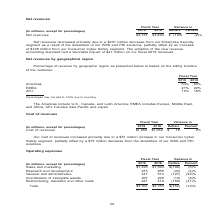According to Nortonlifelock's financial document, Why did Amortization of intangible assets decrease primarily due to? Based on the financial document, the answer is intangible assets sold with the divestiture of WSS and PKI solutions. Also, What is the decrease in  Sales and marketing from Fiscal year 2018 to 2019? According to the financial document, 100 (in millions). The relevant text states: "percentages) Sales and marketing $1,493 $1,593 $(100) (6)% Research and development 913 956 (43) (4)% General and administrative 447 574 (127) (22)% Amo..." Also, What is the decrease in  Research and development  from Fiscal year 2018 to 2019? According to the financial document, 43 (in millions). The relevant text states: "593 $(100) (6)% Research and development 913 956 (43) (4)% General and administrative 447 574 (127) (22)% Amortization of intangible assets 207 220 (13)..." Also, can you calculate: What is the total operating expense of fiscal years 2018 and 2019? Based on the calculation: 3,301+3,753, the result is 7054 (in millions). This is based on the information: "Total $3,301 $3,753 $(452) (12)% Total $3,301 $3,753 $(452) (12)%..." The key data points involved are: 3,301, 3,753. Also, can you calculate: What is the total impact on the decrease in Sales and marketing expense from stock-based compensation expense and divestiture of our WSS and PKI solutions? Based on the calculation: 51+41, the result is 92 (in millions). This is based on the information: "turing, transition and other costs 241 410 (169) (41)% ur cost of revenues increased primarily due to a $51 million increase in our Consumer Cyber Safety segment, partially offset by a $37 million dec..." The key data points involved are: 41, 51. Also, can you calculate: What is the average Sales and marketing expenses for fiscal years 2019 and 2018?  To answer this question, I need to perform calculations using the financial data. The calculation is: (1,493+1,593)/2, which equals 1543 (in millions). This is based on the information: "cept for percentages) Sales and marketing $1,493 $1,593 $(100) (6)% Research and development 913 956 (43) (4)% General and administrative 447 574 (127) (22 ons, except for percentages) Sales and marke..." The key data points involved are: 1,493, 1,593. 